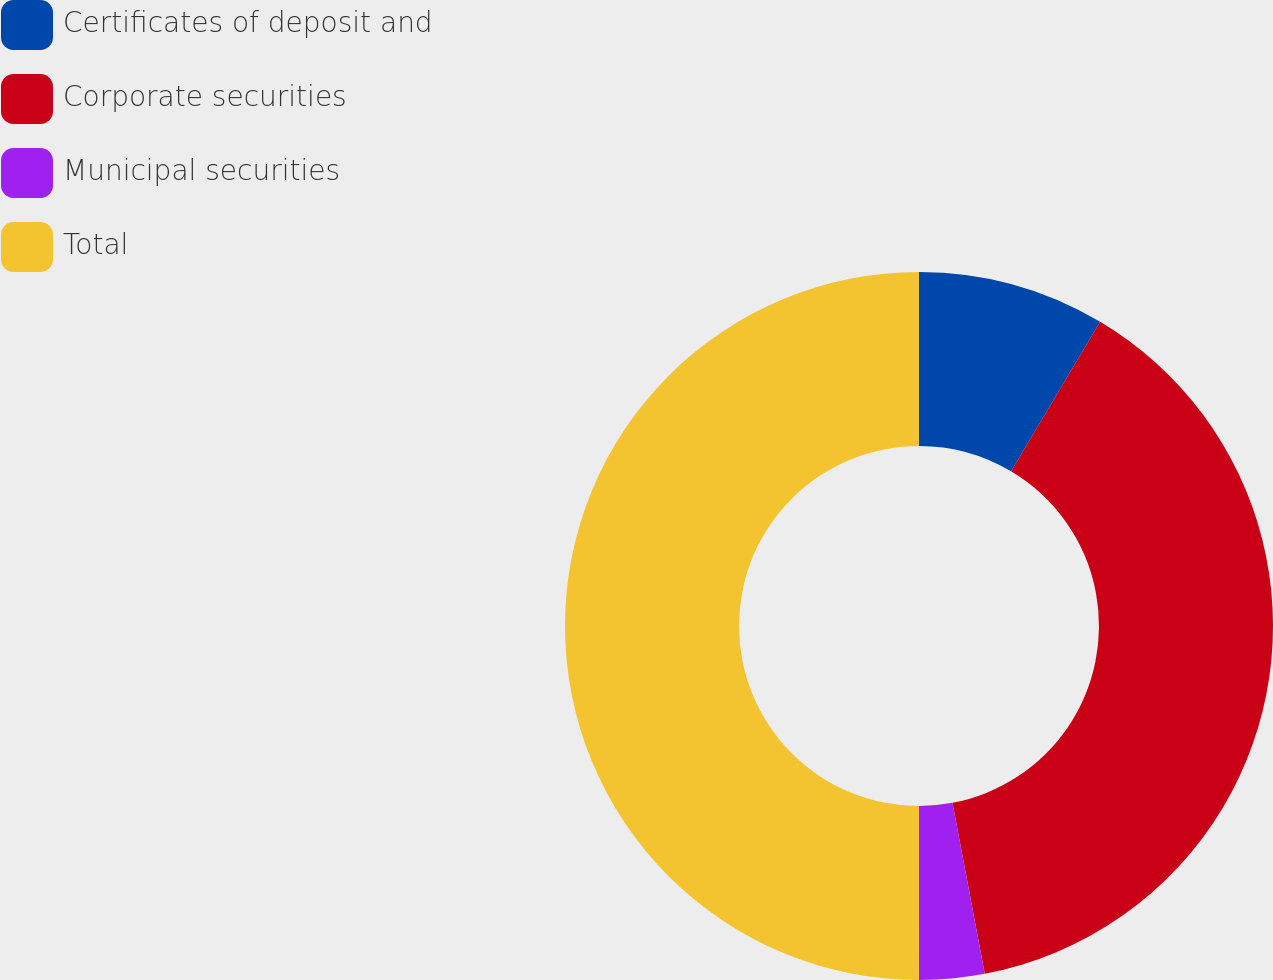Convert chart to OTSL. <chart><loc_0><loc_0><loc_500><loc_500><pie_chart><fcel>Certificates of deposit and<fcel>Corporate securities<fcel>Municipal securities<fcel>Total<nl><fcel>8.55%<fcel>38.48%<fcel>2.98%<fcel>50.0%<nl></chart> 